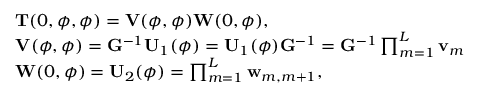<formula> <loc_0><loc_0><loc_500><loc_500>\begin{array} { r l } & { T ( 0 , \phi , \phi ) = V ( \phi , \phi ) W ( 0 , \phi ) , } \\ & { V ( \phi , \phi ) = G ^ { - 1 } U _ { 1 } ( \phi ) = U _ { 1 } ( \phi ) G ^ { - 1 } = G ^ { - 1 } \prod _ { m = 1 } ^ { L } v _ { m } } \\ & { W ( 0 , \phi ) = U _ { 2 } ( \phi ) = \prod _ { m = 1 } ^ { L } w _ { m , m + 1 } , } \end{array}</formula> 